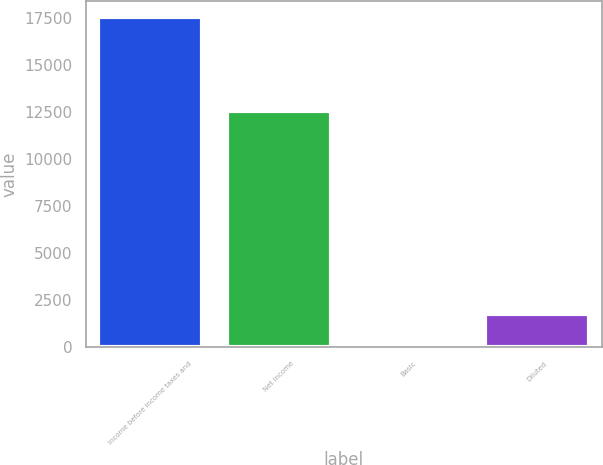Convert chart to OTSL. <chart><loc_0><loc_0><loc_500><loc_500><bar_chart><fcel>Income before income taxes and<fcel>Net income<fcel>Basic<fcel>Diluted<nl><fcel>17542<fcel>12574<fcel>0.12<fcel>1754.31<nl></chart> 